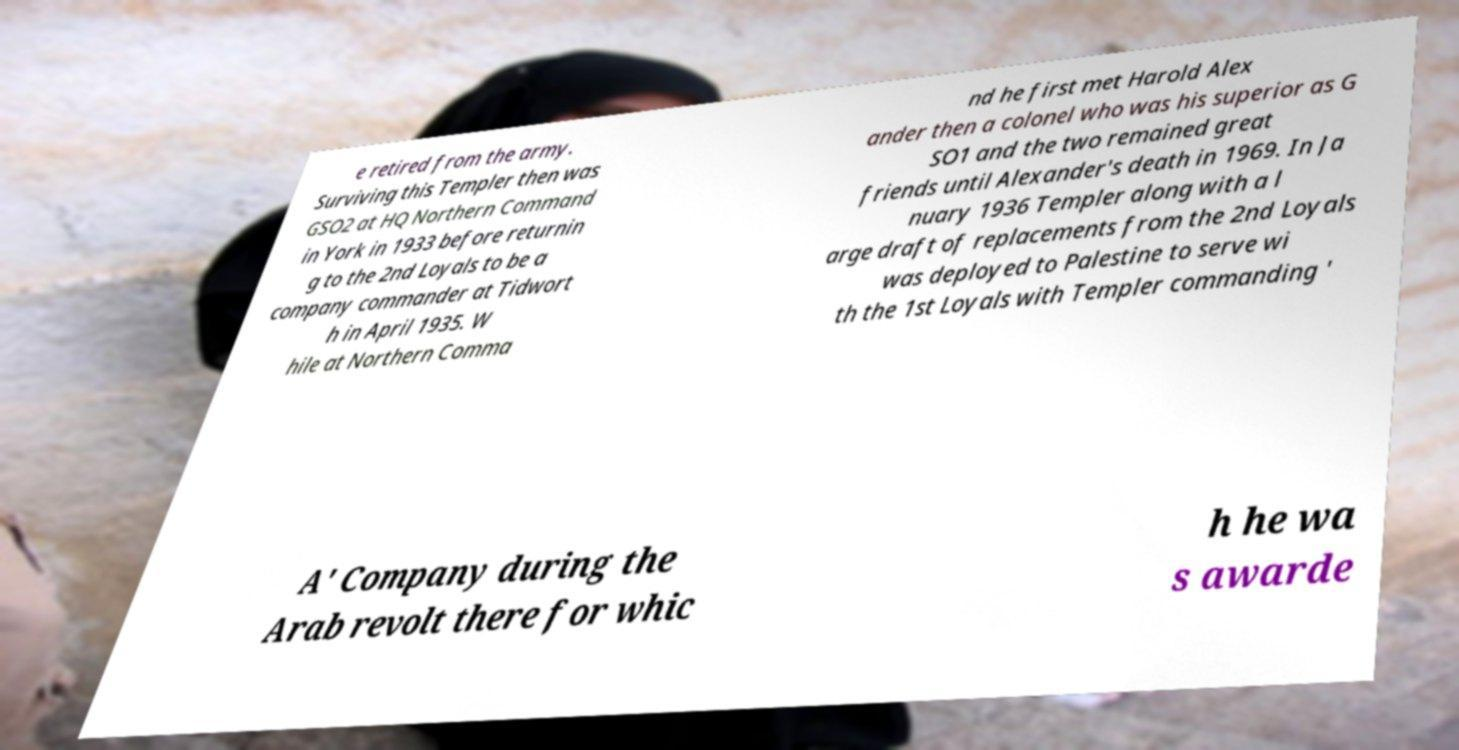I need the written content from this picture converted into text. Can you do that? e retired from the army. Surviving this Templer then was GSO2 at HQ Northern Command in York in 1933 before returnin g to the 2nd Loyals to be a company commander at Tidwort h in April 1935. W hile at Northern Comma nd he first met Harold Alex ander then a colonel who was his superior as G SO1 and the two remained great friends until Alexander's death in 1969. In Ja nuary 1936 Templer along with a l arge draft of replacements from the 2nd Loyals was deployed to Palestine to serve wi th the 1st Loyals with Templer commanding ' A' Company during the Arab revolt there for whic h he wa s awarde 